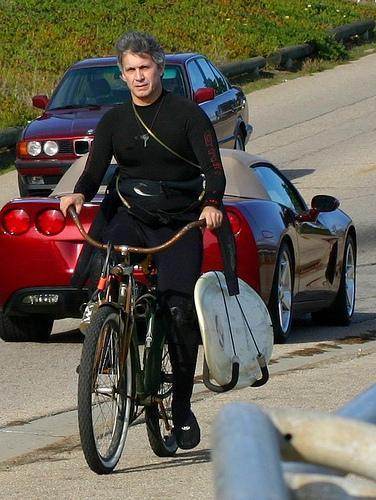How many cars are visible?
Give a very brief answer. 2. How many men are there?
Give a very brief answer. 1. How many cars are there?
Give a very brief answer. 2. 